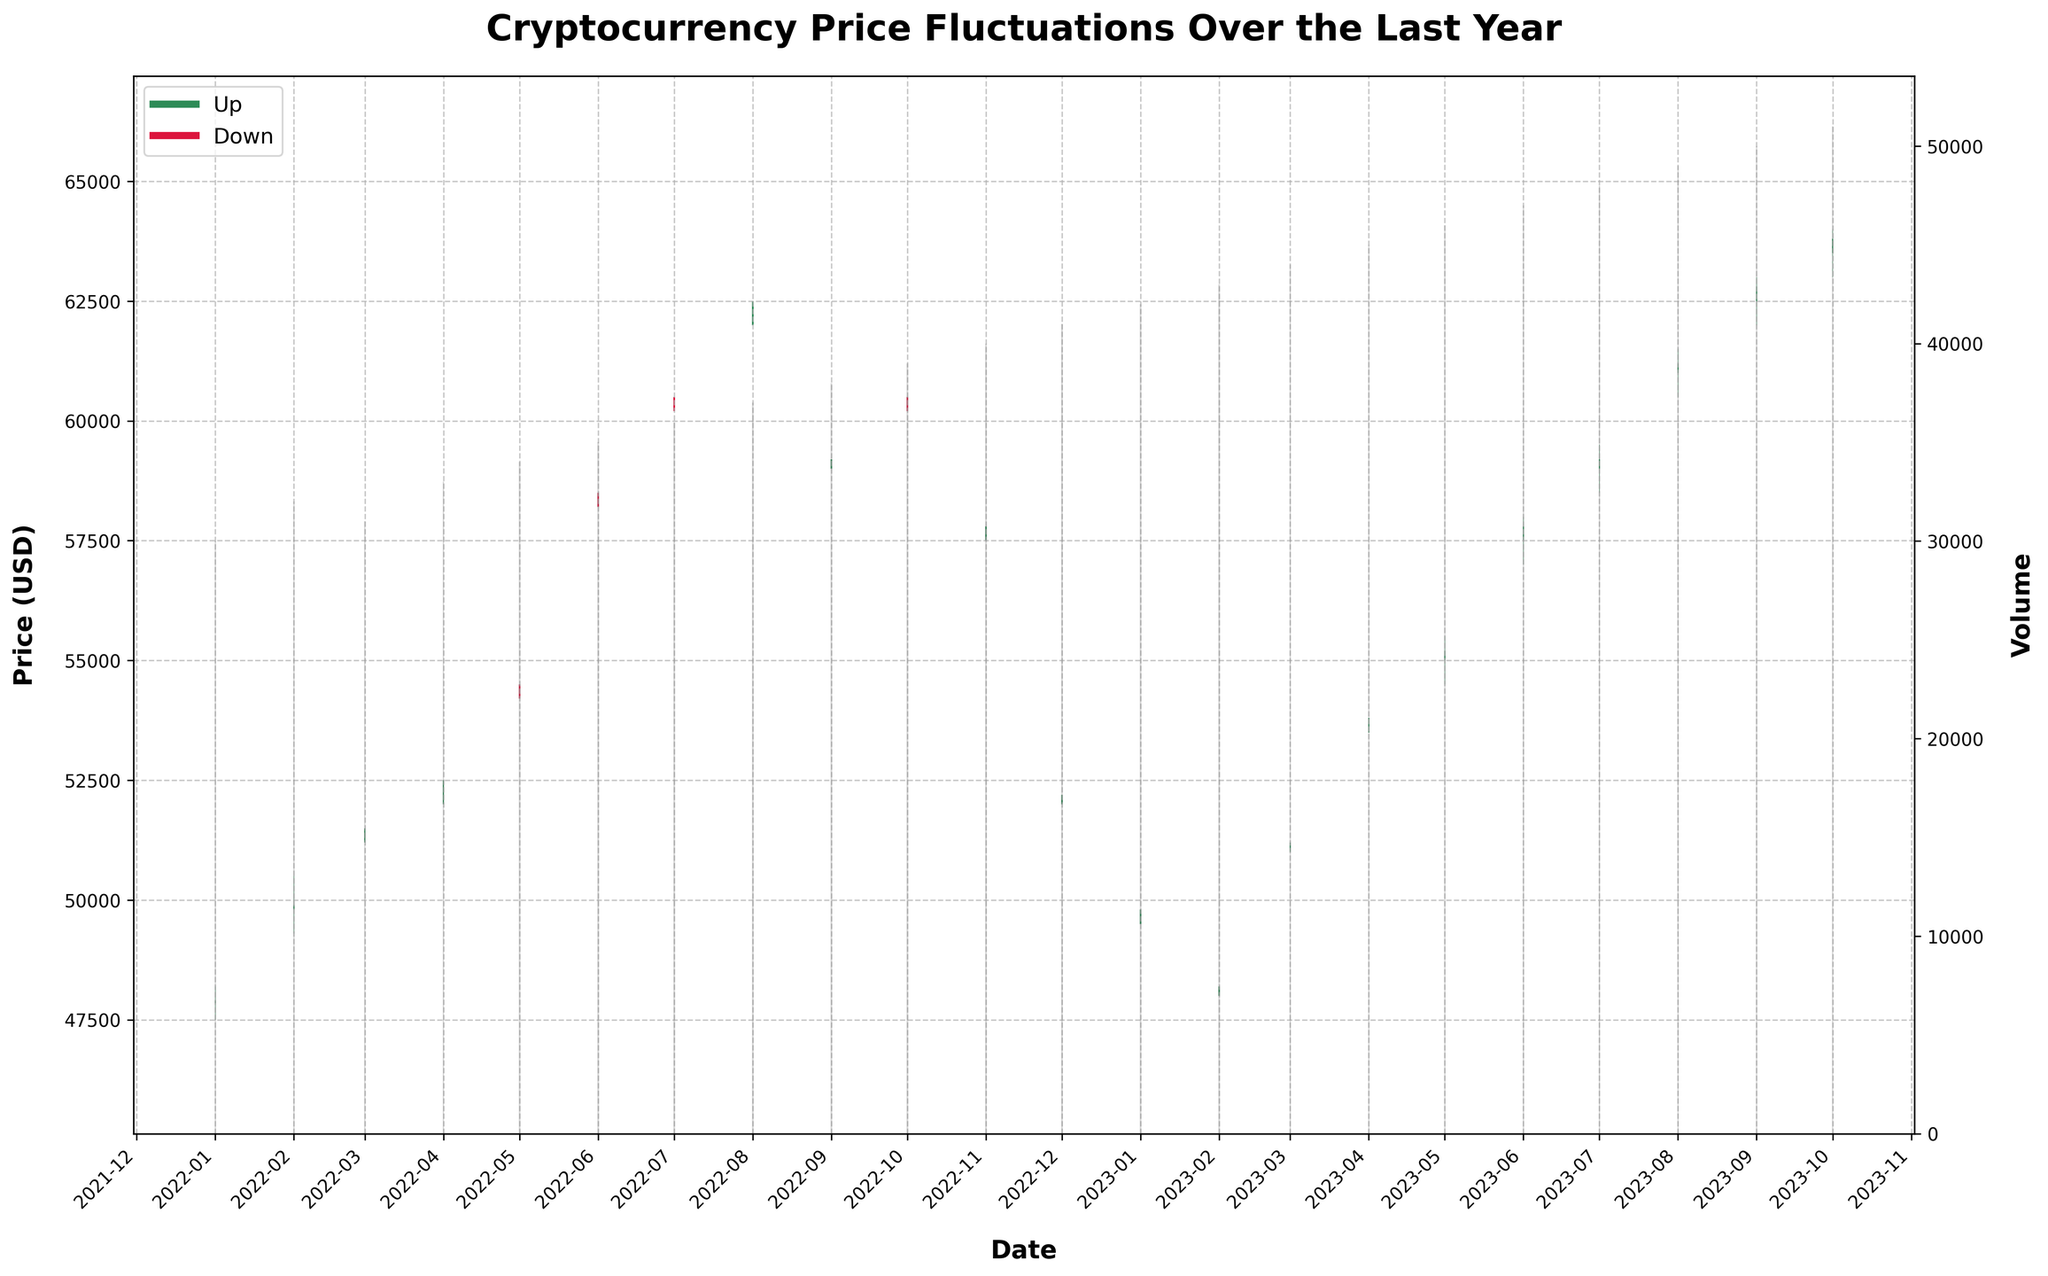What is the title of the figure? The title is usually placed at the top of the figure inside the main plot area and is written in a bold and large font.
Answer: Cryptocurrency Price Fluctuations Over the Last Year How is the x-axis labeled? The x-axis label is typically found near the bottom horizontal line of the figure in a bold font.
Answer: Date What is the color representation for upward and downward price movements? In the figure, the bars representing upward price movements are colored in seagreen, while those representing downward price movements are colored in crimson.
Answer: Upward: seagreen, Downward: crimson How many points on the plot show a downward closing price compared to the opening price? Count the number of red candlesticks to determine the points that show a decrease in price from open to close.
Answer: 5 Which month had the highest closing price? Compare the closing prices across all months, identified by the top of the candlestick body, and determine which one is the highest.
Answer: October 2023 Compare the trading volume in January 2023 and February 2023. Which one is higher? Check the height of the gray volume bars corresponding to these two months and compare them.
Answer: February 2023 What month had the lowest low price during the period? Examine the bottom of the candlestick wicks to find the lowest point across all months.
Answer: February 2023 How many months had a trading volume higher than 35000? Count the number of gray volume bars that extend above the 35000 mark on the secondary y-axis (right side).
Answer: 14 